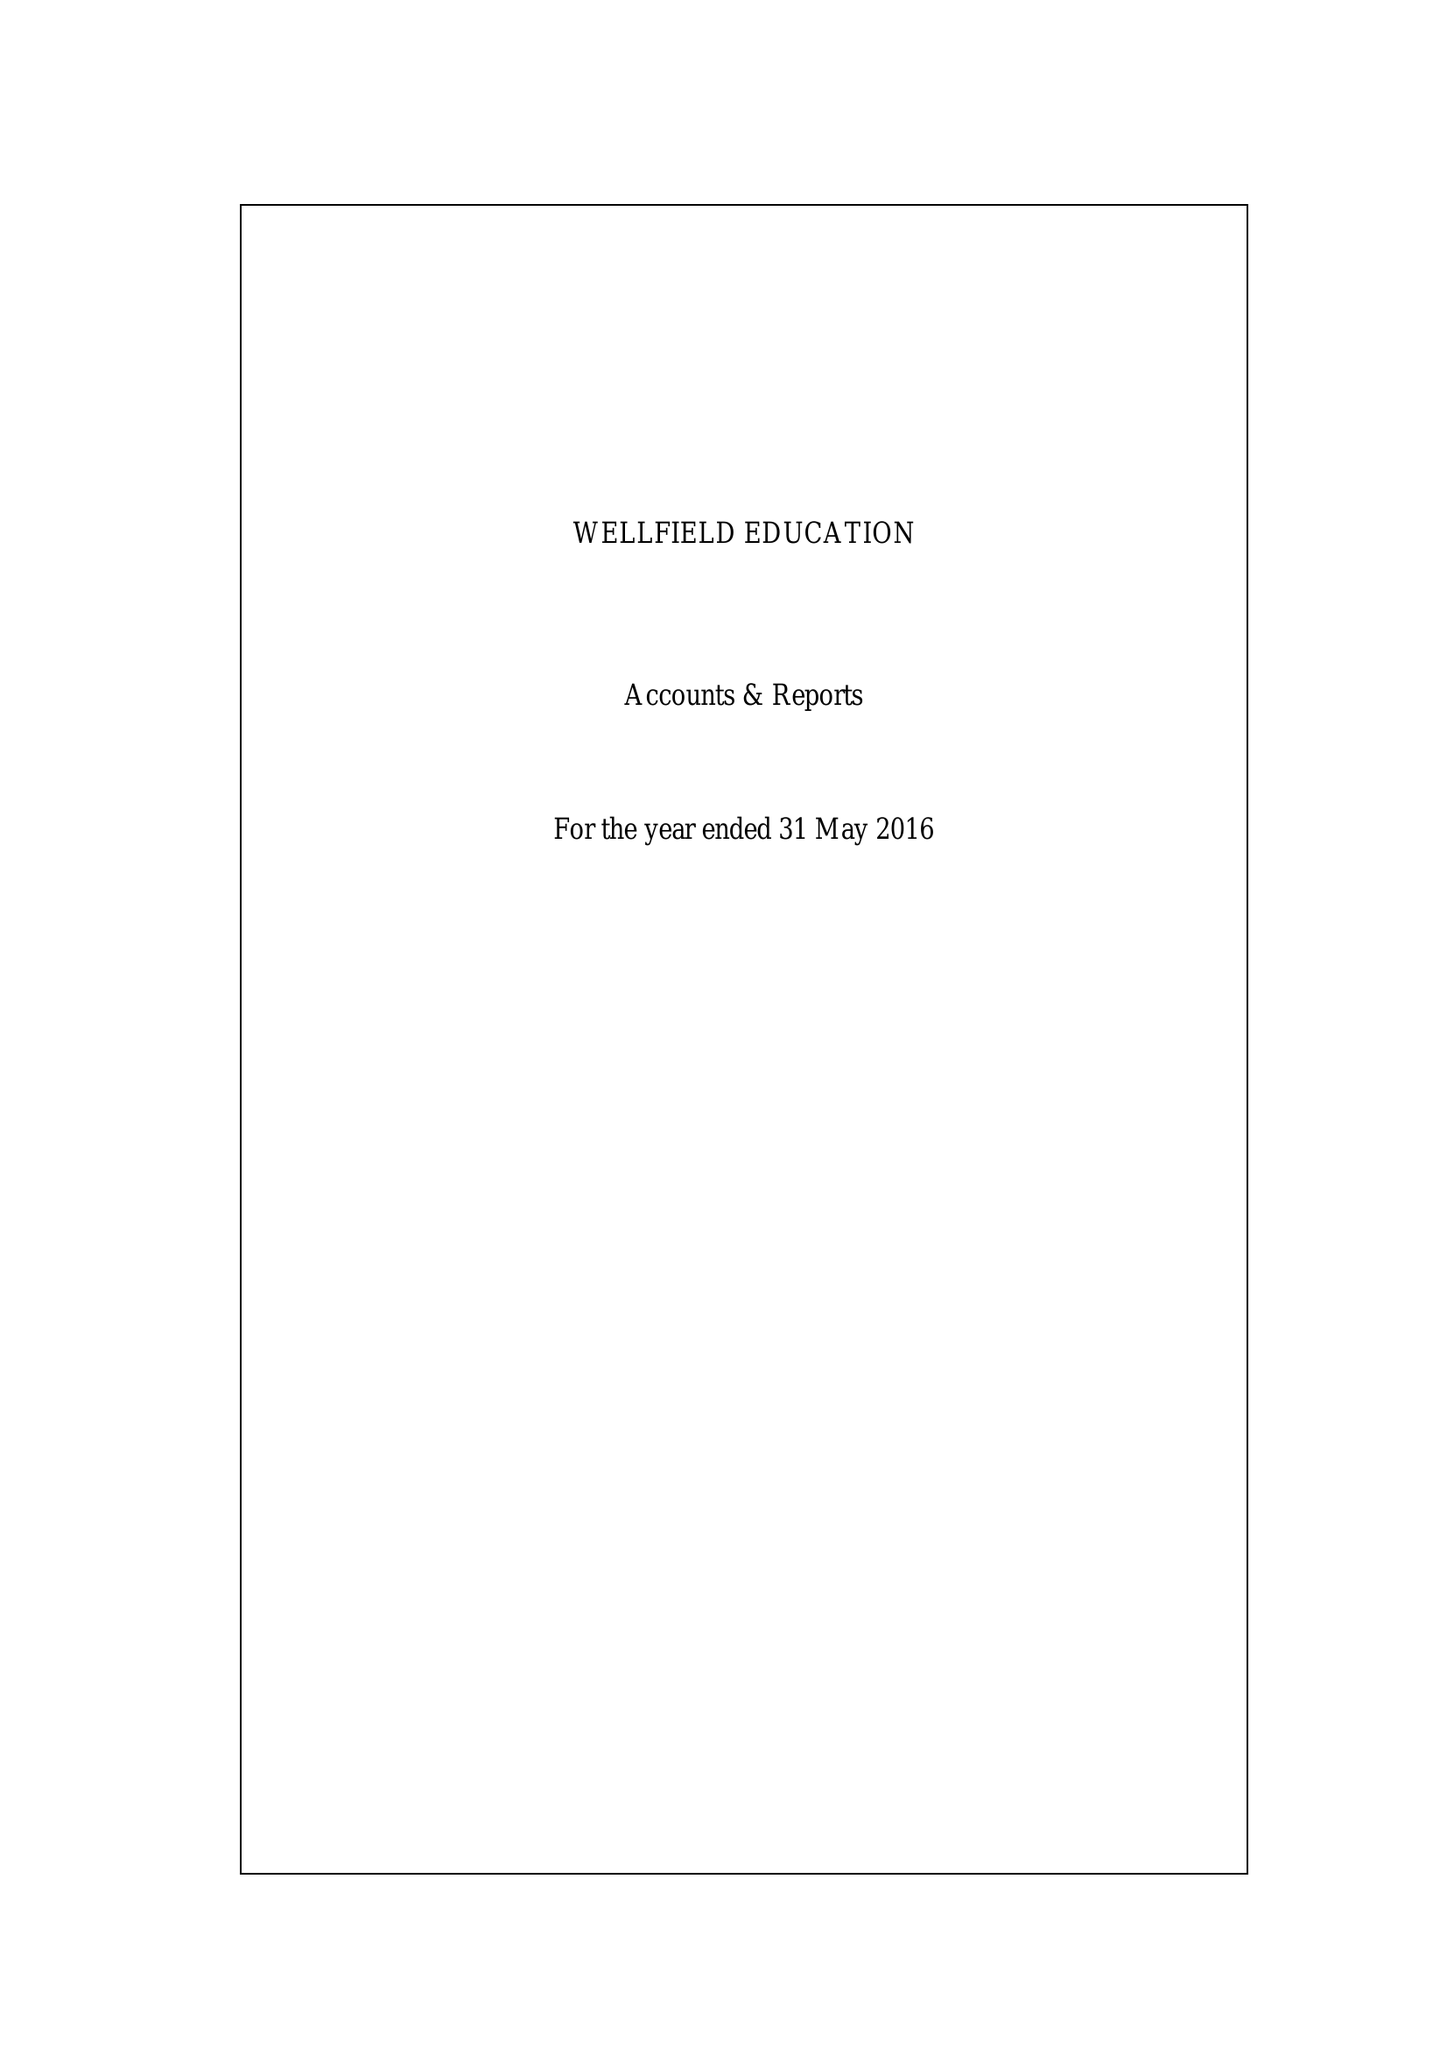What is the value for the spending_annually_in_british_pounds?
Answer the question using a single word or phrase. 173233.00 